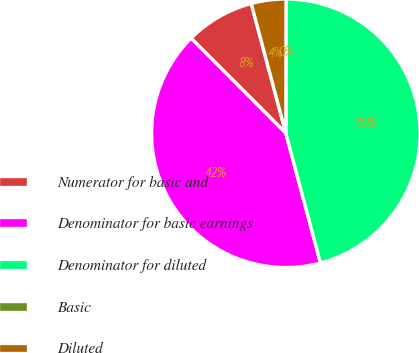Convert chart. <chart><loc_0><loc_0><loc_500><loc_500><pie_chart><fcel>Numerator for basic and<fcel>Denominator for basic earnings<fcel>Denominator for diluted<fcel>Basic<fcel>Diluted<nl><fcel>8.33%<fcel>41.67%<fcel>45.83%<fcel>0.0%<fcel>4.17%<nl></chart> 